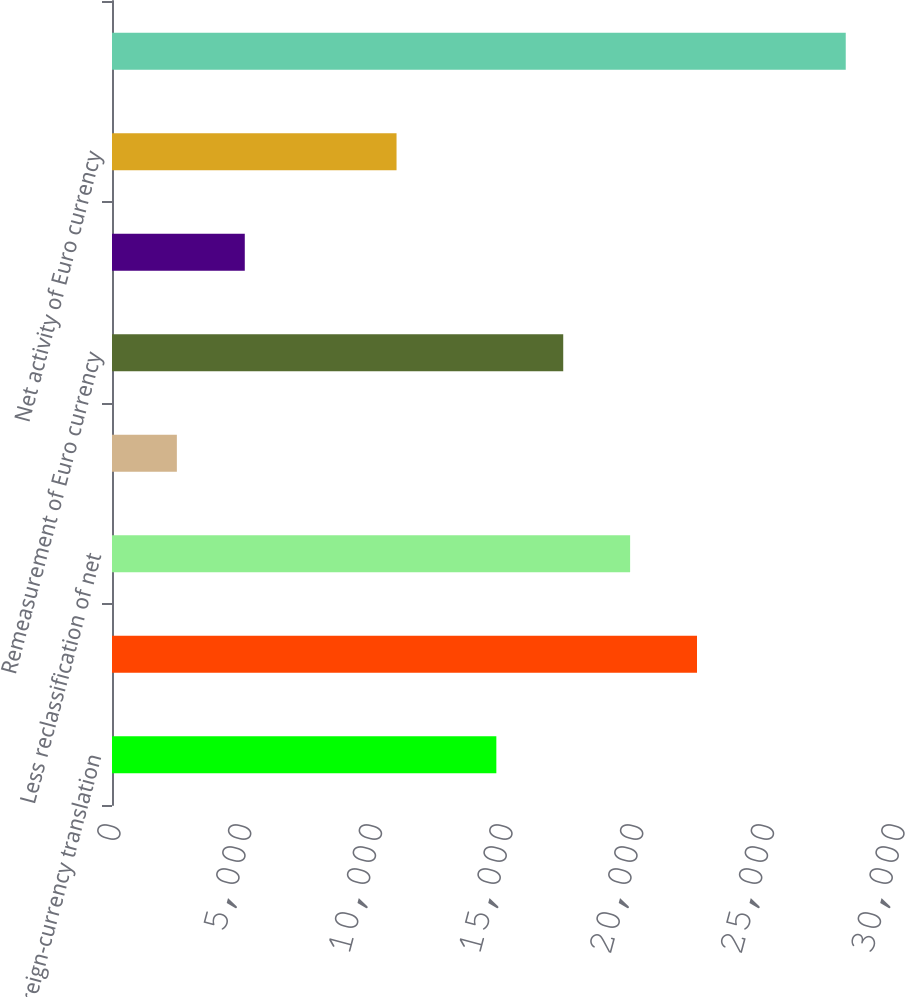Convert chart. <chart><loc_0><loc_0><loc_500><loc_500><bar_chart><fcel>Foreign-currency translation<fcel>Unrealized gains (losses)<fcel>Less reclassification of net<fcel>Net unrealized gains on<fcel>Remeasurement of Euro currency<fcel>Reclassification of (gains)<fcel>Net activity of Euro currency<fcel>Othercomprehensiveincome(loss)<nl><fcel>14707<fcel>22385.5<fcel>19826<fcel>2482<fcel>17266.5<fcel>5081<fcel>10888<fcel>28077<nl></chart> 